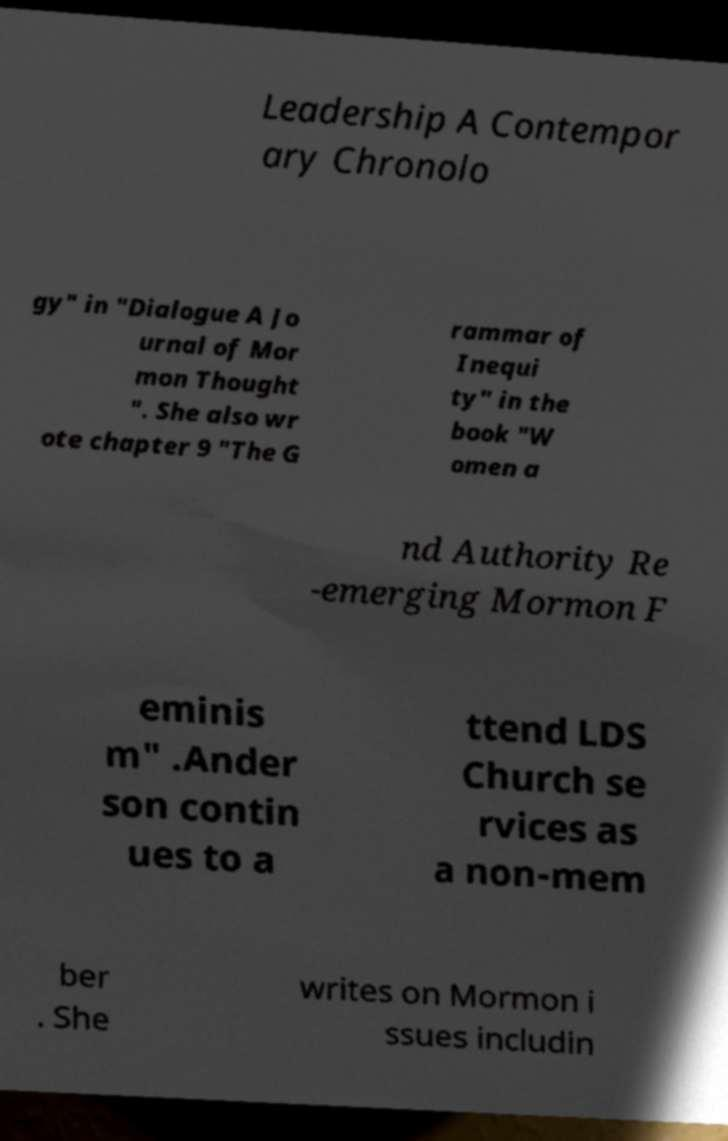Could you assist in decoding the text presented in this image and type it out clearly? Leadership A Contempor ary Chronolo gy" in "Dialogue A Jo urnal of Mor mon Thought ". She also wr ote chapter 9 "The G rammar of Inequi ty" in the book "W omen a nd Authority Re -emerging Mormon F eminis m" .Ander son contin ues to a ttend LDS Church se rvices as a non-mem ber . She writes on Mormon i ssues includin 